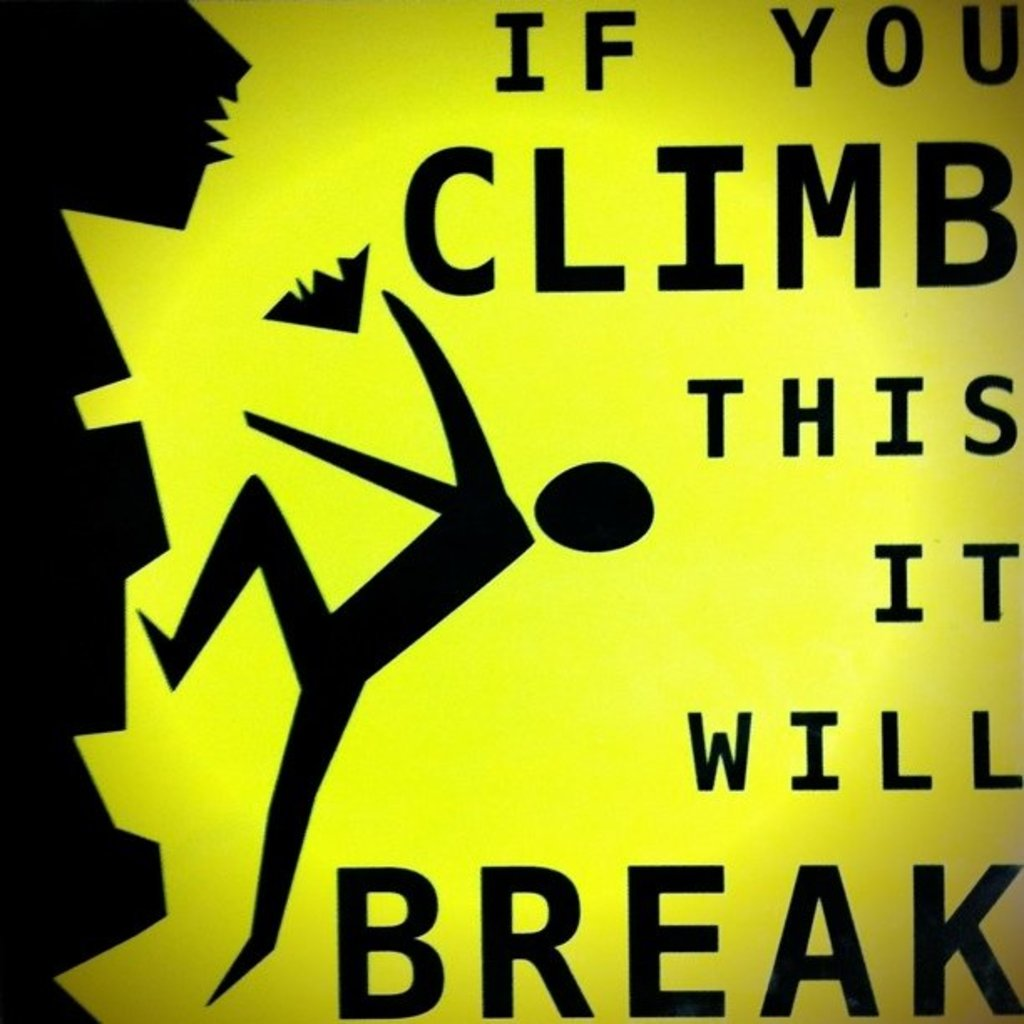What specific details make this warning sign effective at conveying its message? The sign uses bright yellow, a color often associated with caution, which grabs attention immediately. The black silhouette against this vivid background stands out, ensuring high visibility. The depiction of the figure with falling parts visually communicates the consequence of ignoring the warning. The simplicity of the text, 'IF YOU CLIMB THIS IT WILL BREAK', clearly conveys the risk without unnecessary details, which is crucial for quick comprehension by passersby. 